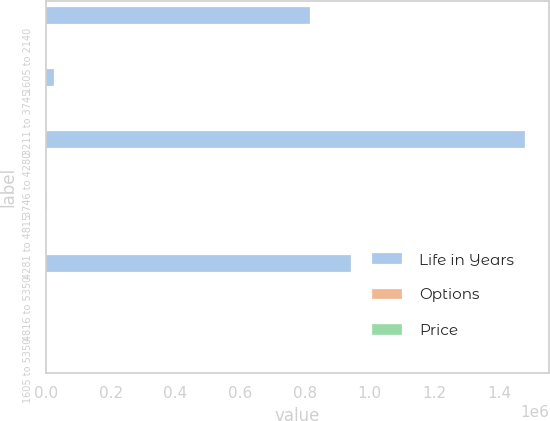<chart> <loc_0><loc_0><loc_500><loc_500><stacked_bar_chart><ecel><fcel>1605 to 2140<fcel>3211 to 3745<fcel>3746 to 4280<fcel>4281 to 4815<fcel>4816 to 5350<fcel>1605 to 5350<nl><fcel>Life in Years<fcel>817375<fcel>26047<fcel>1.48129e+06<fcel>3992<fcel>943693<fcel>32.54<nl><fcel>Options<fcel>1.53<fcel>6.75<fcel>7.98<fcel>8.51<fcel>8.96<fcel>5.74<nl><fcel>Price<fcel>20.55<fcel>32.54<fcel>42.12<fcel>45.33<fcel>53.5<fcel>32.37<nl></chart> 